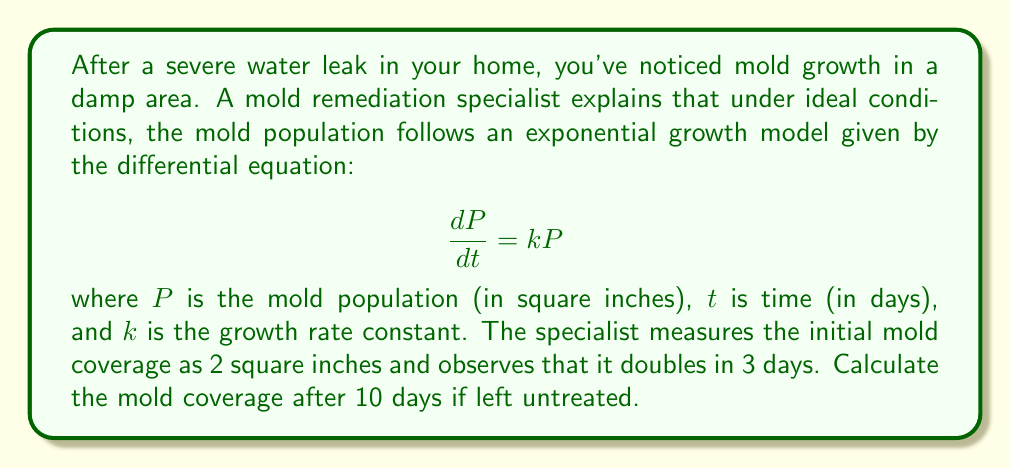Can you solve this math problem? To solve this problem, we'll follow these steps:

1) First, we need to find the growth rate constant $k$. We can use the given information that the mold doubles in 3 days.

2) The general solution to the differential equation $\frac{dP}{dt} = kP$ is:

   $$P(t) = P_0e^{kt}$$

   where $P_0$ is the initial population.

3) We know that $P_0 = 2$ sq inches, and after 3 days, $P(3) = 4$ sq inches (doubled).

4) Substituting these values into the general solution:

   $$4 = 2e^{3k}$$

5) Solving for $k$:

   $$2 = e^{3k}$$
   $$\ln 2 = 3k$$
   $$k = \frac{\ln 2}{3} \approx 0.231$$

6) Now that we have $k$, we can use the general solution to find the mold coverage after 10 days:

   $$P(10) = 2e^{0.231 * 10}$$

7) Calculate the result:

   $$P(10) = 2e^{2.31} \approx 20.09$$

Therefore, after 10 days, the mold coverage will be approximately 20.09 square inches.
Answer: 20.09 square inches 